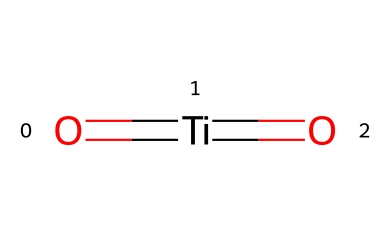What is the oxidation state of titanium in this compound? In the structure provided, titanium is bonded to two oxygen atoms via double bonds. Oxygen typically has an oxidation state of -2, and since there are two oxygen atoms, they contribute a total of -4. To balance the charges, titanium must have an oxidation state of +4.
Answer: +4 How many double bonds are present in this chemical structure? The SMILES representation shows "O=[Ti]=O", indicating two double bonds: one between titanium and the first oxygen and another between titanium and the second oxygen. Therefore, the total number of double bonds is 2.
Answer: 2 What is the primary function of photocatalytic titanium dioxide in self-cleaning materials? Photocatalytic titanium dioxide primarily acts as a photocatalyst, which means it facilitates chemical reactions under light exposure, specifically helping in breaking down organic dirt and contaminants upon UV light activation.
Answer: photocatalyst What types of bonds are present in this compound? The structure indicates that titanium is forming double bonds with both of the oxygen atoms. Since it involves sharing two pairs of electrons, the type of bonds present in this compound is classified as double bonds.
Answer: double bonds Is titanium dioxide considered a semiconductor? Yes, titanium dioxide is classified as a semiconductor because it possesses a bandgap that allows for the conduction of electricity under the influence of light, enabling its photocatalytic properties.
Answer: yes What is the role of oxygen in this chemical structure? In this compound, oxygen serves as an oxidizing agent due to its high electronegativity and ability to form double bonds with titanium. This contributes to the overall photocatalytic activity of the material when exposed to light.
Answer: oxidizing agent 